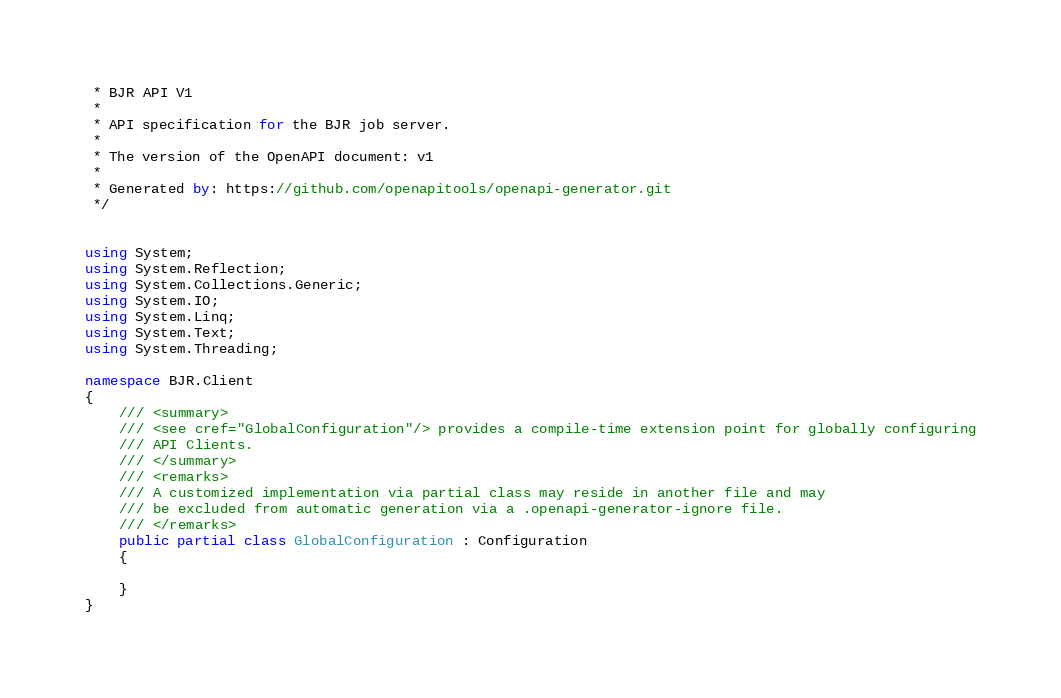Convert code to text. <code><loc_0><loc_0><loc_500><loc_500><_C#_> * BJR API V1
 *
 * API specification for the BJR job server.
 *
 * The version of the OpenAPI document: v1
 * 
 * Generated by: https://github.com/openapitools/openapi-generator.git
 */


using System;
using System.Reflection;
using System.Collections.Generic;
using System.IO;
using System.Linq;
using System.Text;
using System.Threading;

namespace BJR.Client
{
    /// <summary>
    /// <see cref="GlobalConfiguration"/> provides a compile-time extension point for globally configuring
    /// API Clients.
    /// </summary>
    /// <remarks>
    /// A customized implementation via partial class may reside in another file and may
    /// be excluded from automatic generation via a .openapi-generator-ignore file.
    /// </remarks>
    public partial class GlobalConfiguration : Configuration
    {

    }
}</code> 